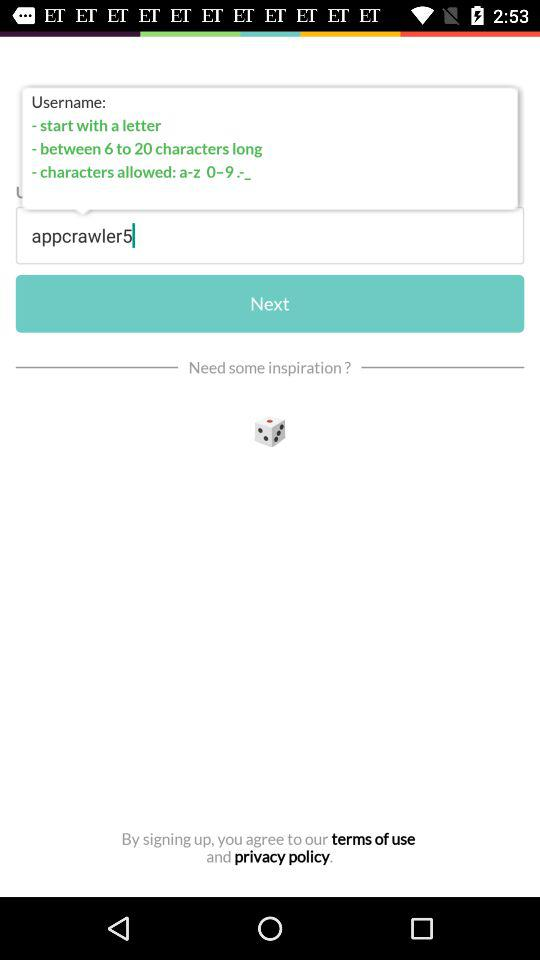How long should a username be? The username should be 6 to 20 characters long. 